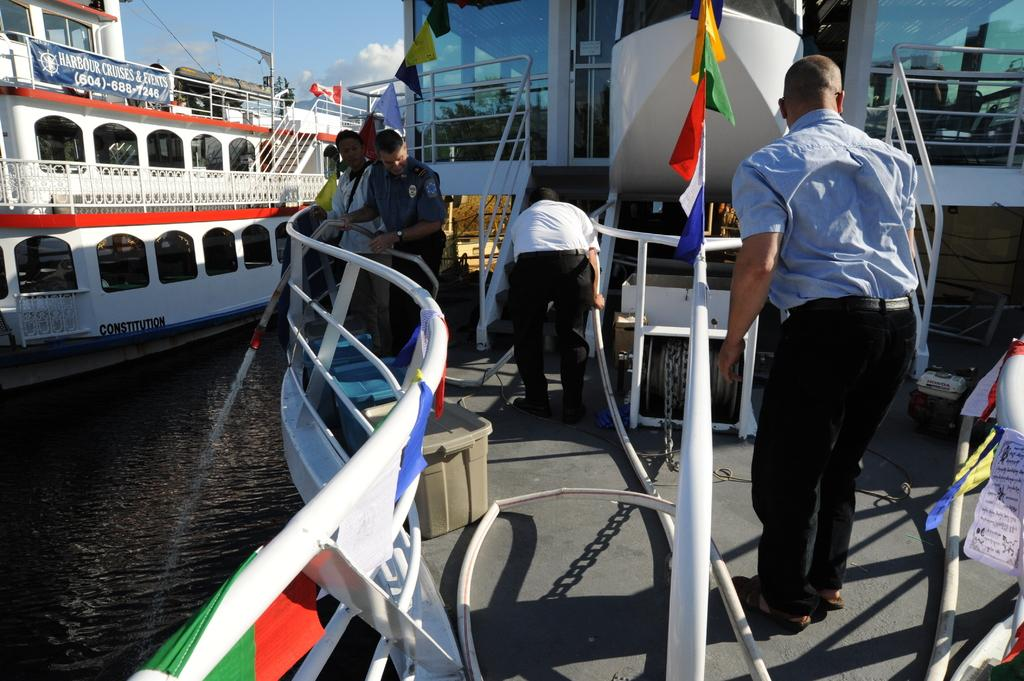What is the main setting of the image? There is a harbor in the image. How many ships can be seen in the harbor? There are two ships in the harbor. Are there any people visible on the ships? Yes, one of the ships has four men on it. What is the color of the sky in the background of the image? There is a blue sky visible in the background of the image. What type of reward is being given to the lead actor in the image? There is no lead actor or reward present in the image; it features a harbor with two ships. 